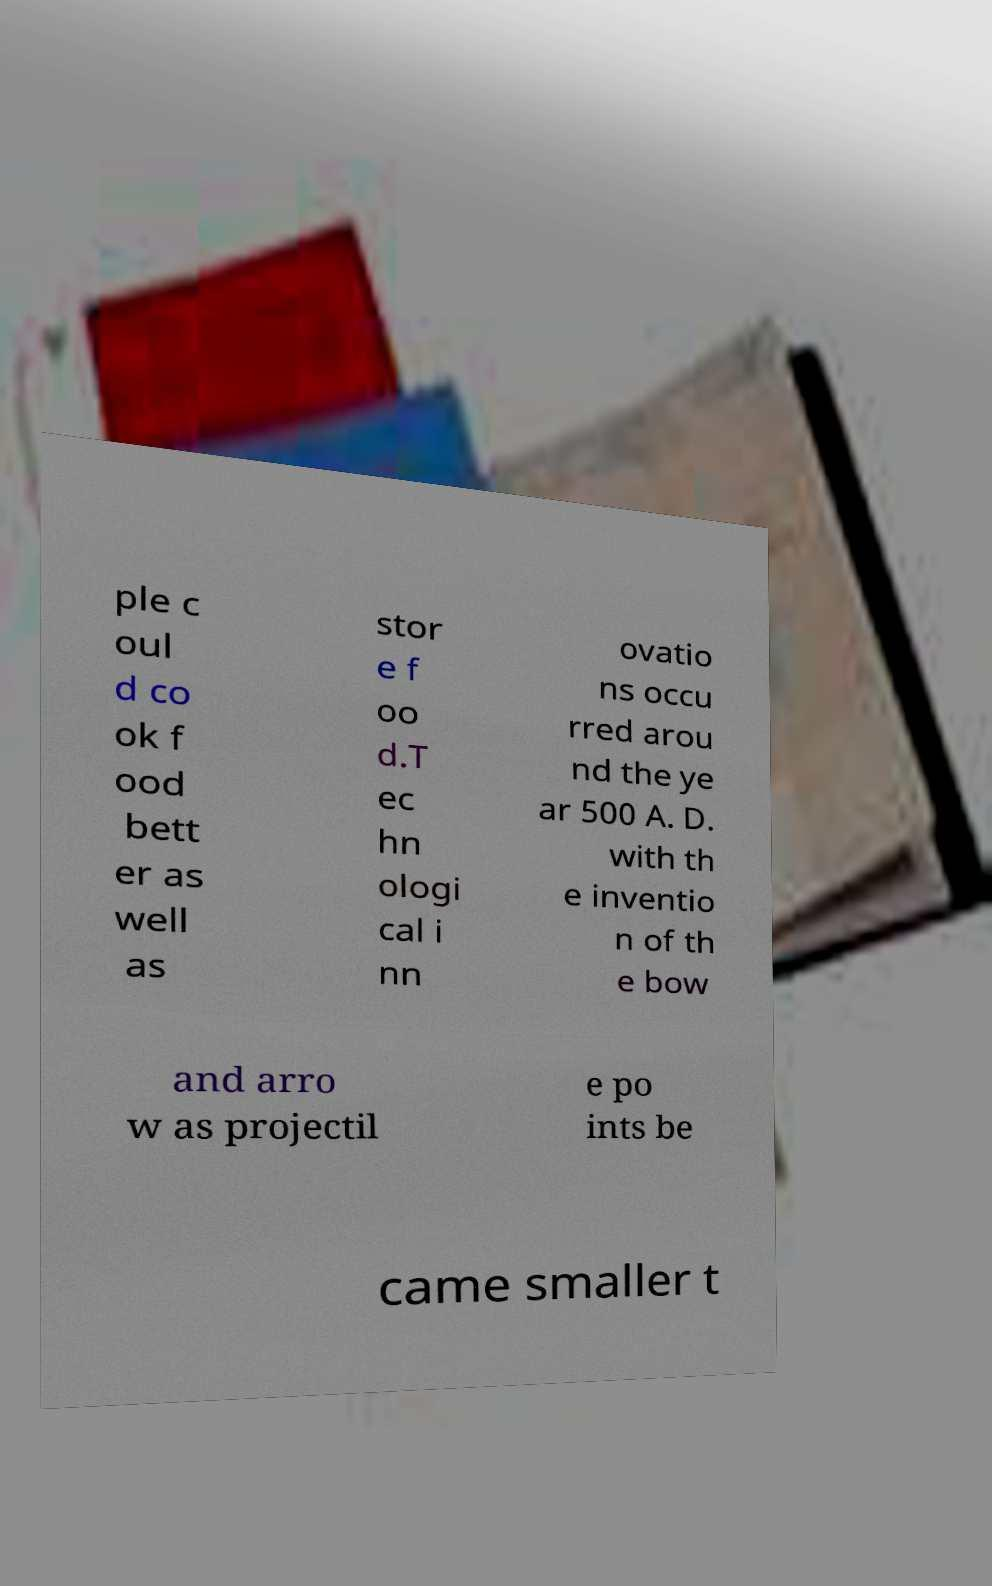There's text embedded in this image that I need extracted. Can you transcribe it verbatim? ple c oul d co ok f ood bett er as well as stor e f oo d.T ec hn ologi cal i nn ovatio ns occu rred arou nd the ye ar 500 A. D. with th e inventio n of th e bow and arro w as projectil e po ints be came smaller t 